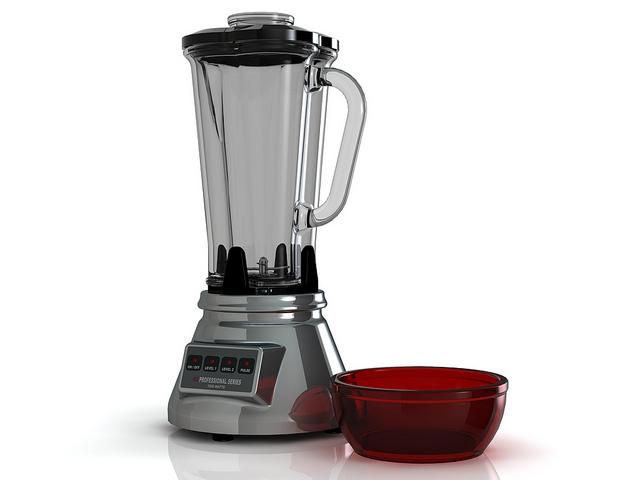Could this be a picture from a magazine?
Give a very brief answer. Yes. Is this Battery powered?
Be succinct. No. Does either container in this picture have food in it?
Give a very brief answer. No. How many options does the blender have?
Write a very short answer. 4. 